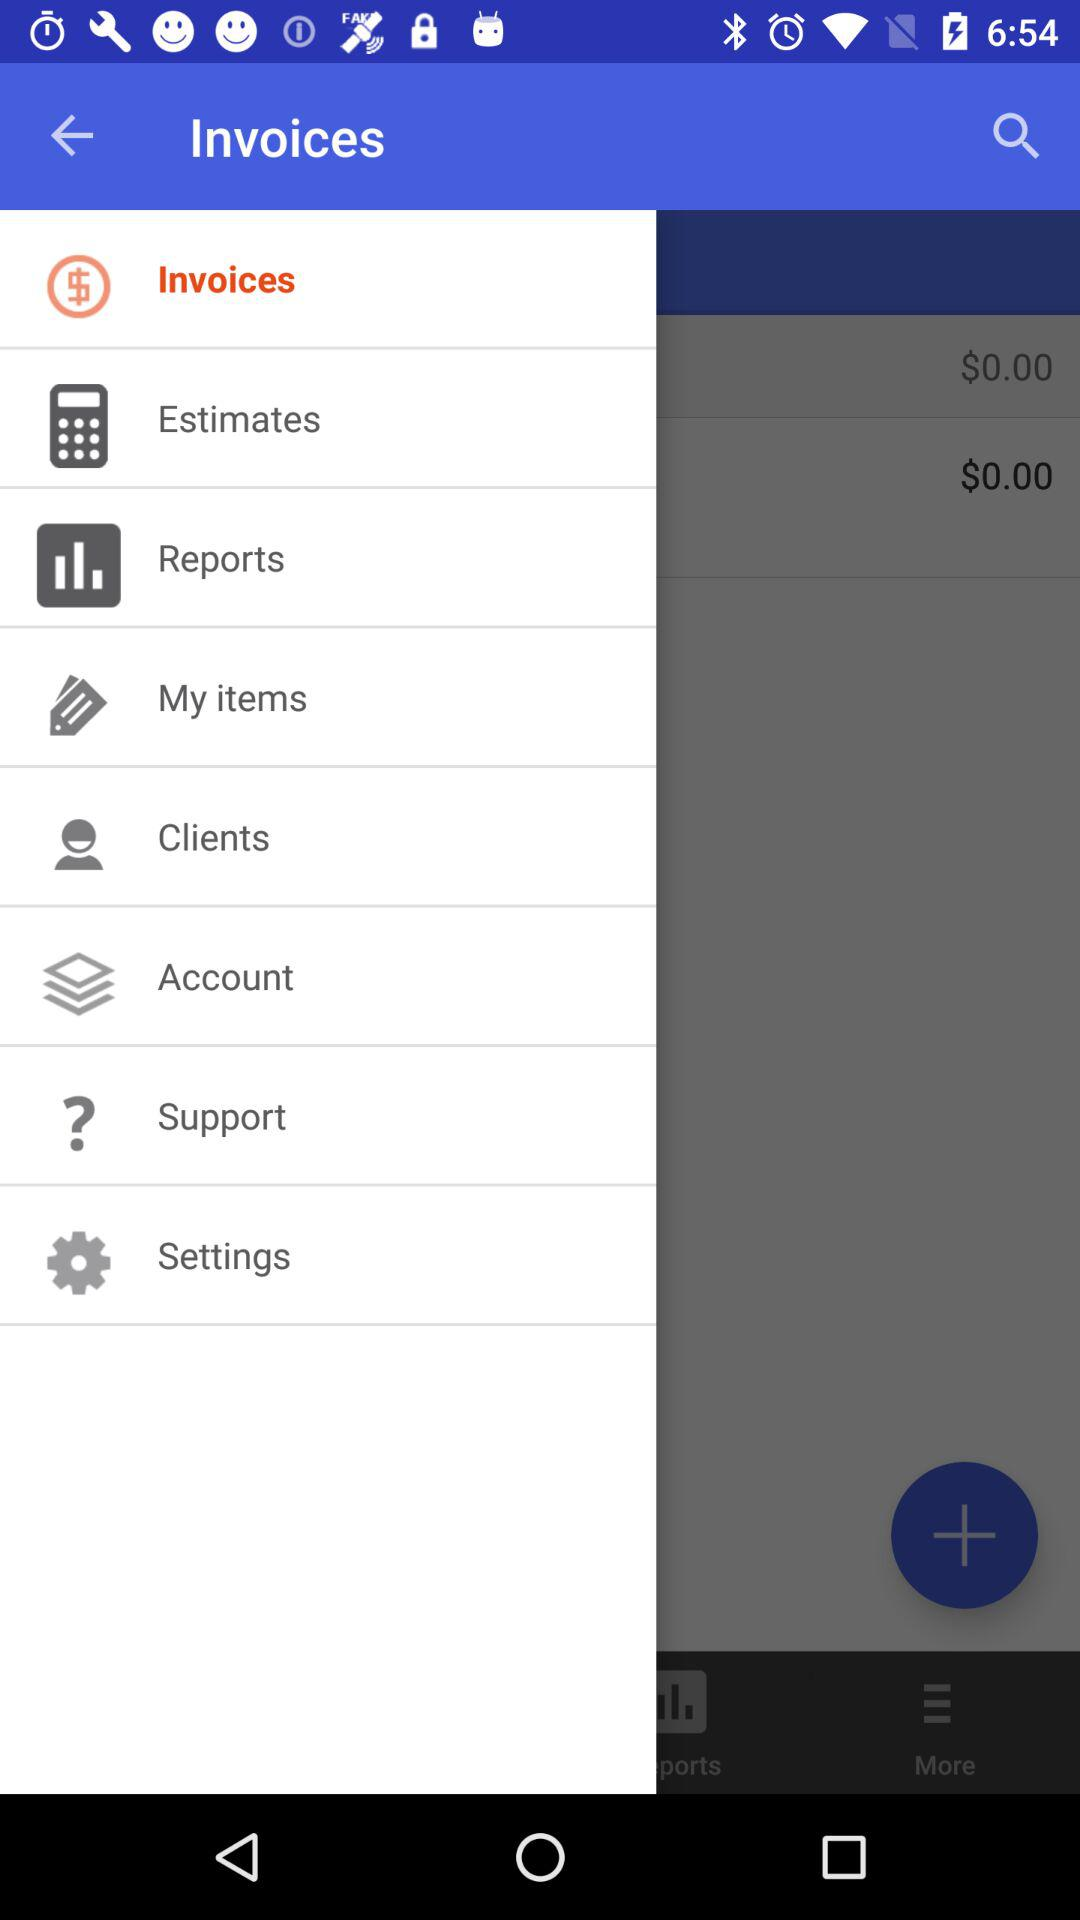Which item is selected in the menu? The selected item is "Invoices". 